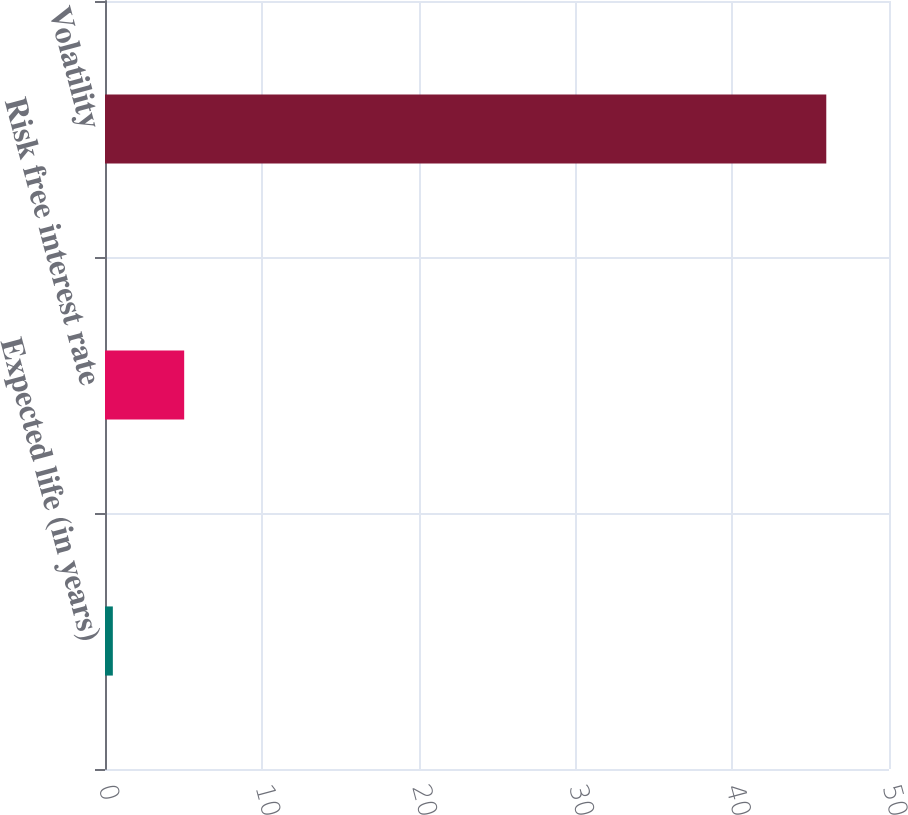Convert chart. <chart><loc_0><loc_0><loc_500><loc_500><bar_chart><fcel>Expected life (in years)<fcel>Risk free interest rate<fcel>Volatility<nl><fcel>0.5<fcel>5.05<fcel>46<nl></chart> 